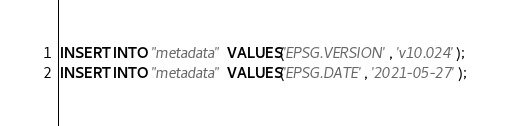Convert code to text. <code><loc_0><loc_0><loc_500><loc_500><_SQL_>
INSERT INTO "metadata" VALUES('EPSG.VERSION', 'v10.024');
INSERT INTO "metadata" VALUES('EPSG.DATE', '2021-05-27');
</code> 